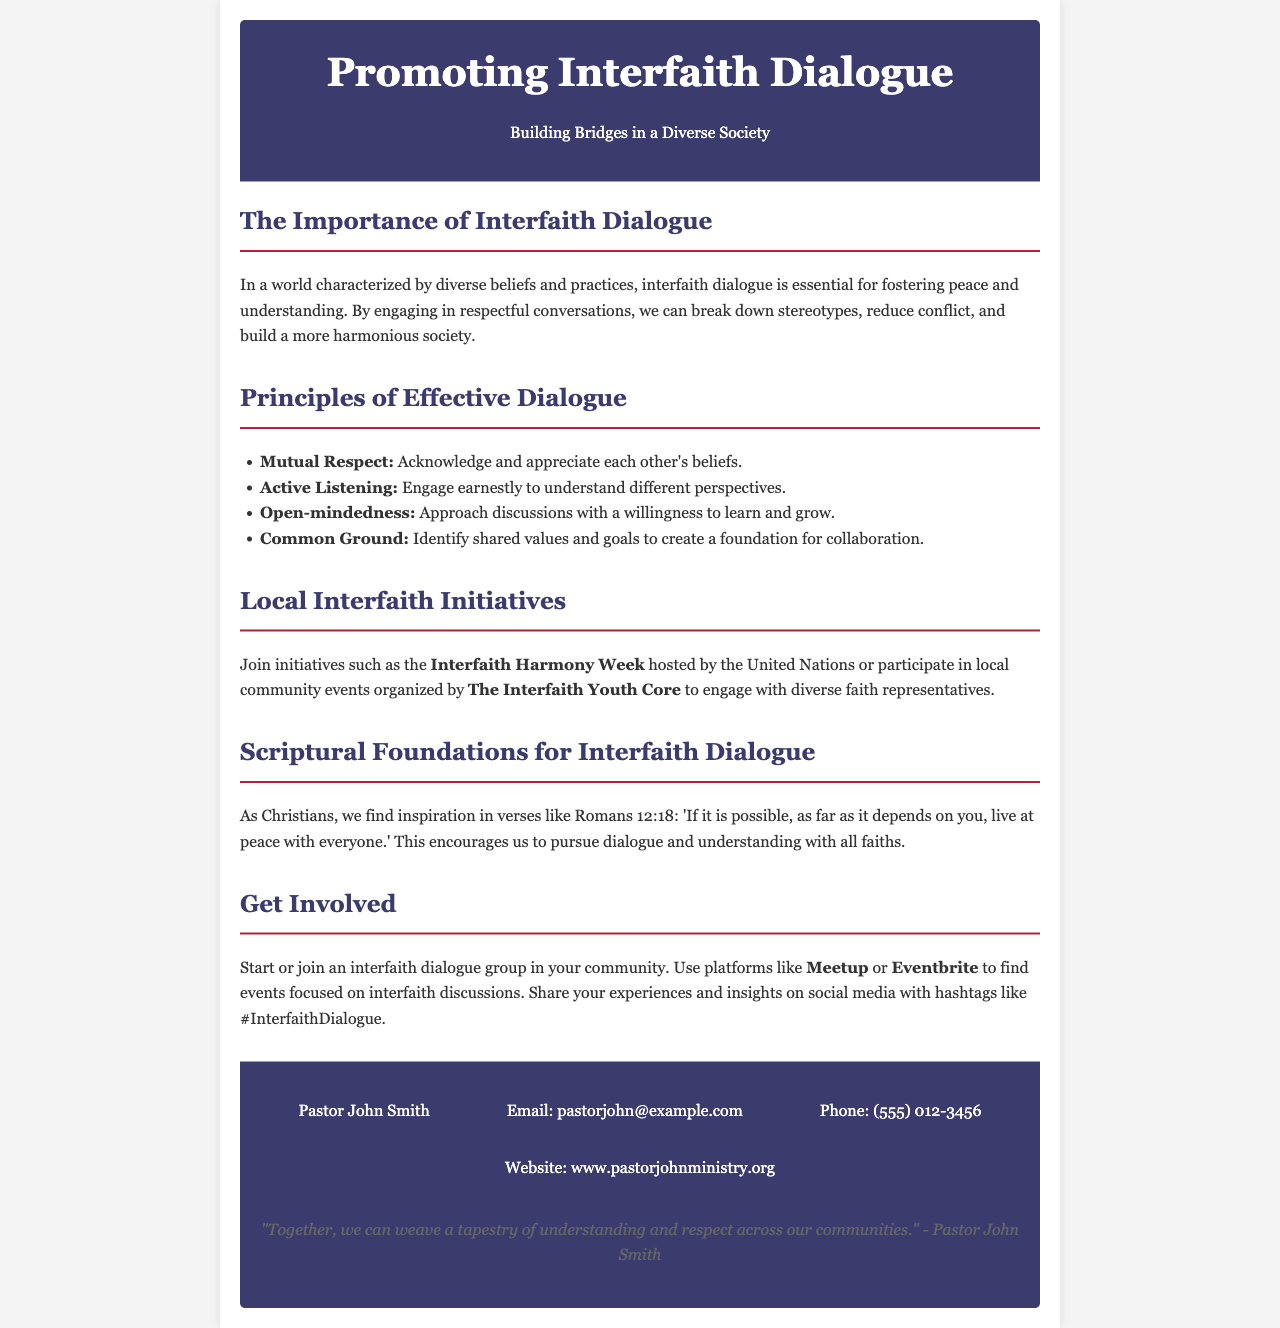What is the title of the brochure? The title, prominently displayed at the top of the document, reflects the main subject matter of the brochure.
Answer: Promoting Interfaith Dialogue What is the purpose of interfaith dialogue according to the document? The brochure describes the purpose of interfaith dialogue in fostering peace and understanding in a diverse society.
Answer: Fostering peace and understanding Who is the author of the quote in the footer? The quote is attributed to an individual whose name is provided in the contact information section of the document.
Answer: Pastor John Smith What principle encourages understanding different perspectives? This principle is one of the key elements listed in the Principles of Effective Dialogue section.
Answer: Active Listening What event is hosted by the United Nations mentioned in the document? The document refers to a specific initiative encouraging interfaith collaboration and participation.
Answer: Interfaith Harmony Week What scriptural verse is provided as inspiration for interfaith dialogue? The document refers to a specific scripture that encourages peaceful interactions among all people.
Answer: Romans 12:18 Which platforms can you use to find interfaith events? The brochure suggests specific platforms for community engagement related to interfaith discussions.
Answer: Meetup or Eventbrite What color is the header background? The document specifies the color scheme used in the header of the brochure.
Answer: Dark Blue 